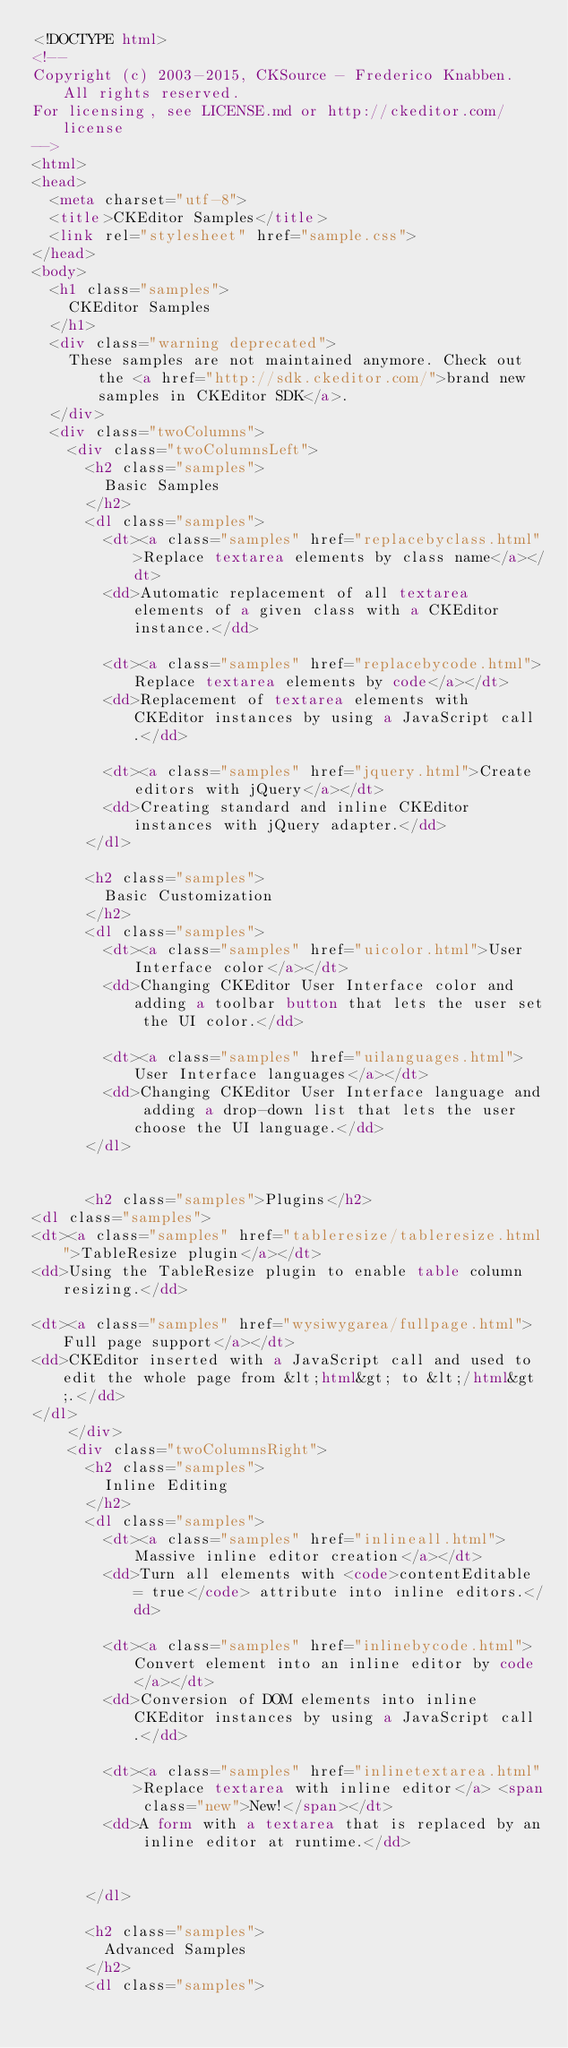Convert code to text. <code><loc_0><loc_0><loc_500><loc_500><_HTML_><!DOCTYPE html>
<!--
Copyright (c) 2003-2015, CKSource - Frederico Knabben. All rights reserved.
For licensing, see LICENSE.md or http://ckeditor.com/license
-->
<html>
<head>
	<meta charset="utf-8">
	<title>CKEditor Samples</title>
	<link rel="stylesheet" href="sample.css">
</head>
<body>
	<h1 class="samples">
		CKEditor Samples
	</h1>
	<div class="warning deprecated">
		These samples are not maintained anymore. Check out the <a href="http://sdk.ckeditor.com/">brand new samples in CKEditor SDK</a>.
	</div>
	<div class="twoColumns">
		<div class="twoColumnsLeft">
			<h2 class="samples">
				Basic Samples
			</h2>
			<dl class="samples">
				<dt><a class="samples" href="replacebyclass.html">Replace textarea elements by class name</a></dt>
				<dd>Automatic replacement of all textarea elements of a given class with a CKEditor instance.</dd>

				<dt><a class="samples" href="replacebycode.html">Replace textarea elements by code</a></dt>
				<dd>Replacement of textarea elements with CKEditor instances by using a JavaScript call.</dd>

				<dt><a class="samples" href="jquery.html">Create editors with jQuery</a></dt>
				<dd>Creating standard and inline CKEditor instances with jQuery adapter.</dd>
			</dl>

			<h2 class="samples">
				Basic Customization
			</h2>
			<dl class="samples">
				<dt><a class="samples" href="uicolor.html">User Interface color</a></dt>
				<dd>Changing CKEditor User Interface color and adding a toolbar button that lets the user set the UI color.</dd>

				<dt><a class="samples" href="uilanguages.html">User Interface languages</a></dt>
				<dd>Changing CKEditor User Interface language and adding a drop-down list that lets the user choose the UI language.</dd>
			</dl>


			<h2 class="samples">Plugins</h2>
<dl class="samples">
<dt><a class="samples" href="tableresize/tableresize.html">TableResize plugin</a></dt>
<dd>Using the TableResize plugin to enable table column resizing.</dd>

<dt><a class="samples" href="wysiwygarea/fullpage.html">Full page support</a></dt>
<dd>CKEditor inserted with a JavaScript call and used to edit the whole page from &lt;html&gt; to &lt;/html&gt;.</dd>
</dl>
		</div>
		<div class="twoColumnsRight">
			<h2 class="samples">
				Inline Editing
			</h2>
			<dl class="samples">
				<dt><a class="samples" href="inlineall.html">Massive inline editor creation</a></dt>
				<dd>Turn all elements with <code>contentEditable = true</code> attribute into inline editors.</dd>

				<dt><a class="samples" href="inlinebycode.html">Convert element into an inline editor by code</a></dt>
				<dd>Conversion of DOM elements into inline CKEditor instances by using a JavaScript call.</dd>

				<dt><a class="samples" href="inlinetextarea.html">Replace textarea with inline editor</a> <span class="new">New!</span></dt>
				<dd>A form with a textarea that is replaced by an inline editor at runtime.</dd>

				
			</dl>

			<h2 class="samples">
				Advanced Samples
			</h2>
			<dl class="samples"></code> 